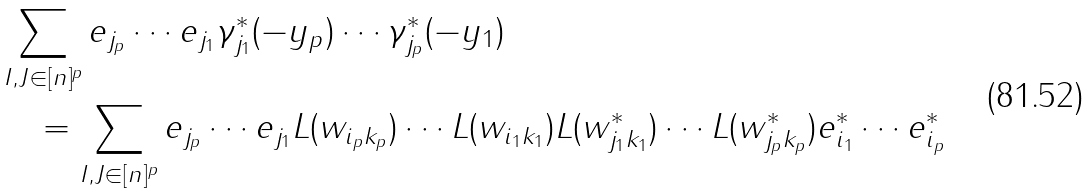Convert formula to latex. <formula><loc_0><loc_0><loc_500><loc_500>& \sum _ { I , J \in [ n ] ^ { p } } e _ { j _ { p } } \cdots e _ { j _ { 1 } } \gamma ^ { * } _ { j _ { 1 } } ( - y _ { p } ) \cdots \gamma ^ { * } _ { j _ { p } } ( - y _ { 1 } ) \\ & \quad = \sum _ { I , J \in [ n ] ^ { p } } e _ { j _ { p } } \cdots e _ { j _ { 1 } } L ( w _ { i _ { p } k _ { p } } ) \cdots L ( w _ { i _ { 1 } k _ { 1 } } ) L ( w ^ { * } _ { j _ { 1 } k _ { 1 } } ) \cdots L ( w ^ { * } _ { j _ { p } k _ { p } } ) e ^ { * } _ { i _ { 1 } } \cdots e ^ { * } _ { i _ { p } }</formula> 